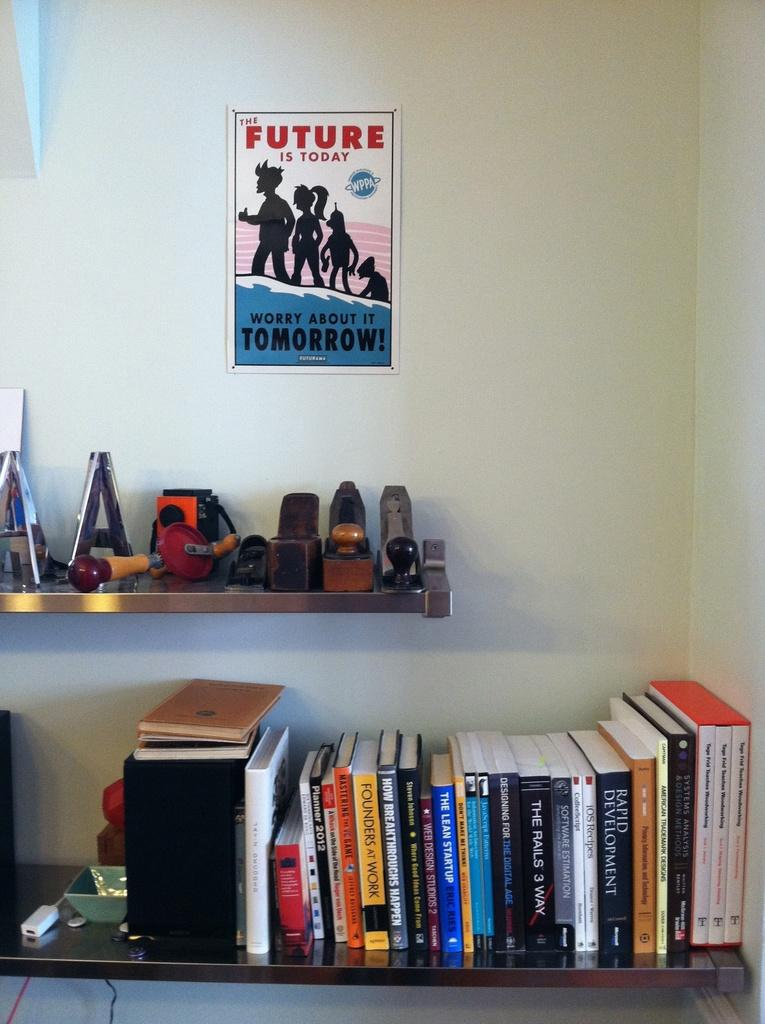What is placed on the rack in the image? There are books placed on a rack in the image. Are there any other objects on the rack besides the books? Yes, there are objects on the rack in the image. What can be seen on the plain wall in the image? There is a poster attached to a plain wall in the image. What type of substance is being used to mark the territory in the image? There is no indication of any territory or substance being used to mark it in the image. 